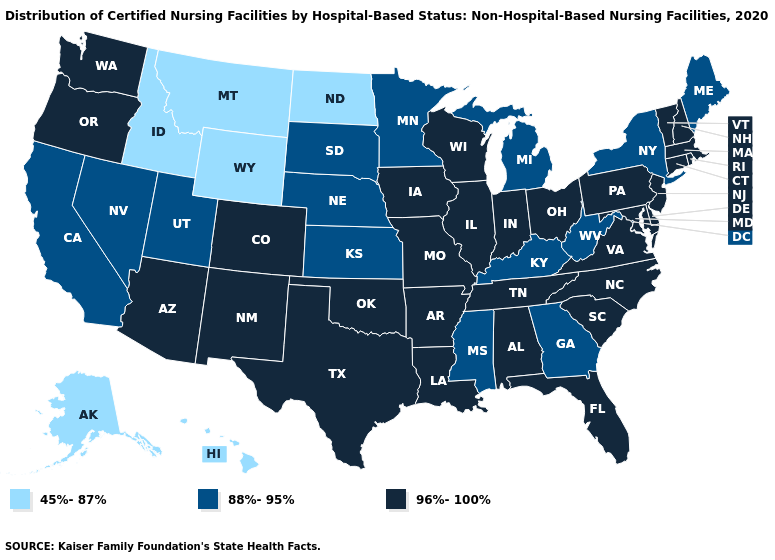Among the states that border New Hampshire , does Massachusetts have the highest value?
Keep it brief. Yes. What is the value of Wyoming?
Quick response, please. 45%-87%. What is the lowest value in states that border New Jersey?
Concise answer only. 88%-95%. What is the highest value in states that border West Virginia?
Be succinct. 96%-100%. Which states have the lowest value in the USA?
Concise answer only. Alaska, Hawaii, Idaho, Montana, North Dakota, Wyoming. Does the first symbol in the legend represent the smallest category?
Short answer required. Yes. Name the states that have a value in the range 45%-87%?
Answer briefly. Alaska, Hawaii, Idaho, Montana, North Dakota, Wyoming. Does Nevada have the same value as Hawaii?
Concise answer only. No. Does Alabama have a higher value than Montana?
Give a very brief answer. Yes. Does Pennsylvania have the same value as Massachusetts?
Short answer required. Yes. Does South Carolina have a lower value than Maryland?
Be succinct. No. What is the highest value in the USA?
Answer briefly. 96%-100%. What is the highest value in the USA?
Keep it brief. 96%-100%. Among the states that border Maryland , which have the highest value?
Concise answer only. Delaware, Pennsylvania, Virginia. 